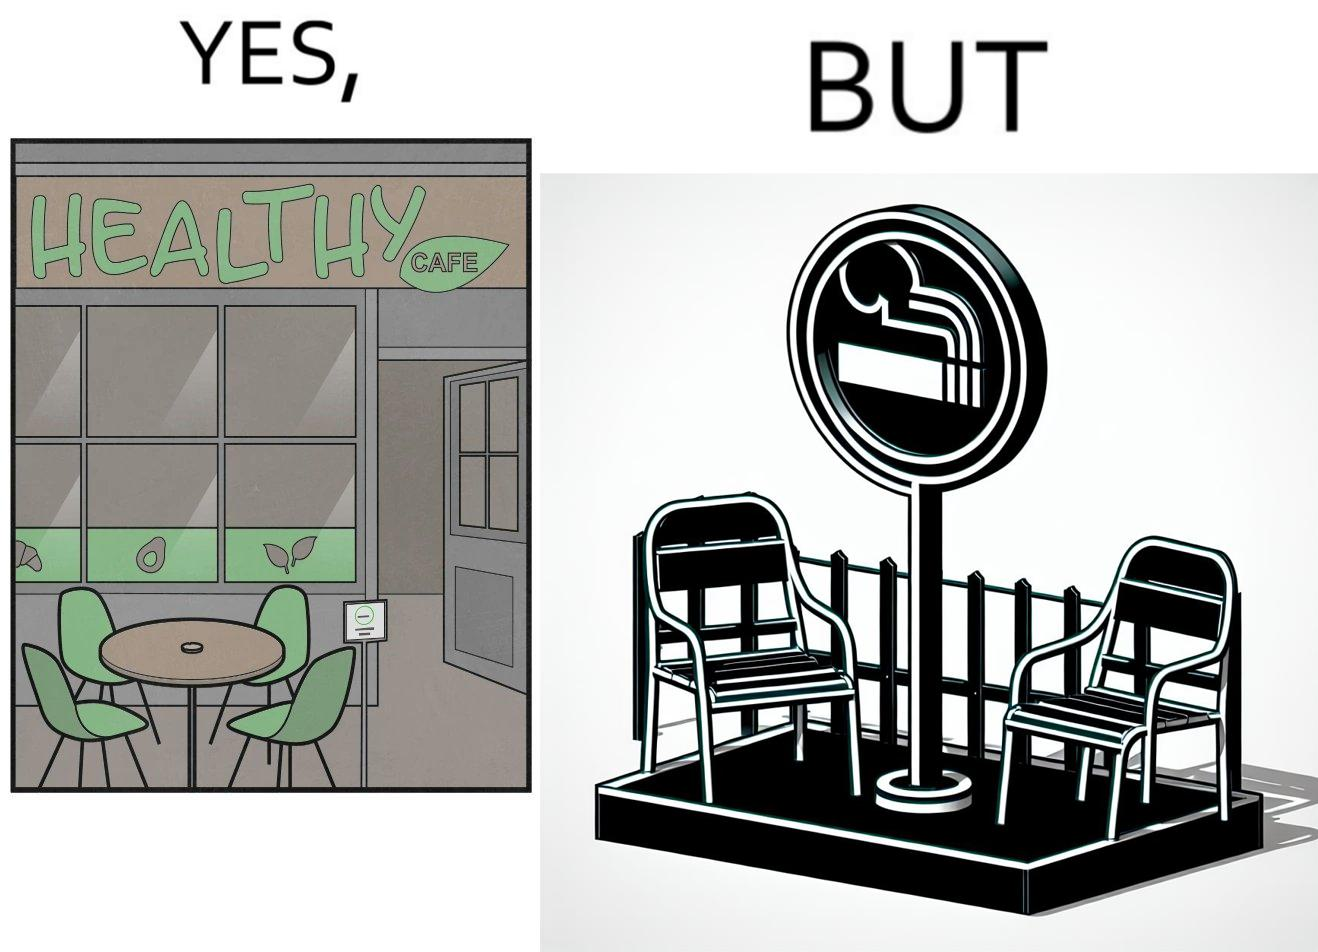Describe the satirical element in this image. This image is funny because an eatery that calls itself the "healthy" cafe also has a smoking area, which is not very "healthy". If it really was a healthy cafe, it would not have a smoking area as smoking is injurious to health. Satire on the behavior of humans - both those that operate this cafe who made the decision of allowing smoking and creating a designated smoking area, and those that visit this healthy cafe to become "healthy", but then also indulge in very unhealthy habits simultaneously. 